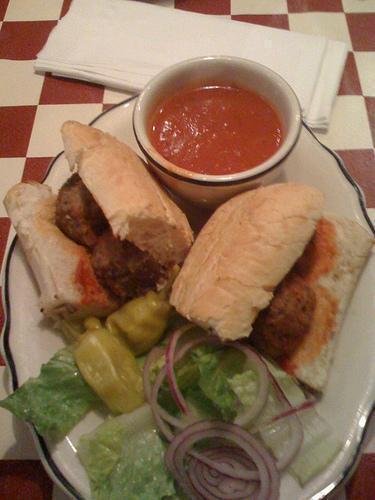What type of pepper is on the plate?
Indicate the correct response and explain using: 'Answer: answer
Rationale: rationale.'
Options: Jalapeno, cherry pepper, pepperoncini, red pepper. Answer: pepperoncini.
Rationale: The pepper is light green, long, with a long stem. 